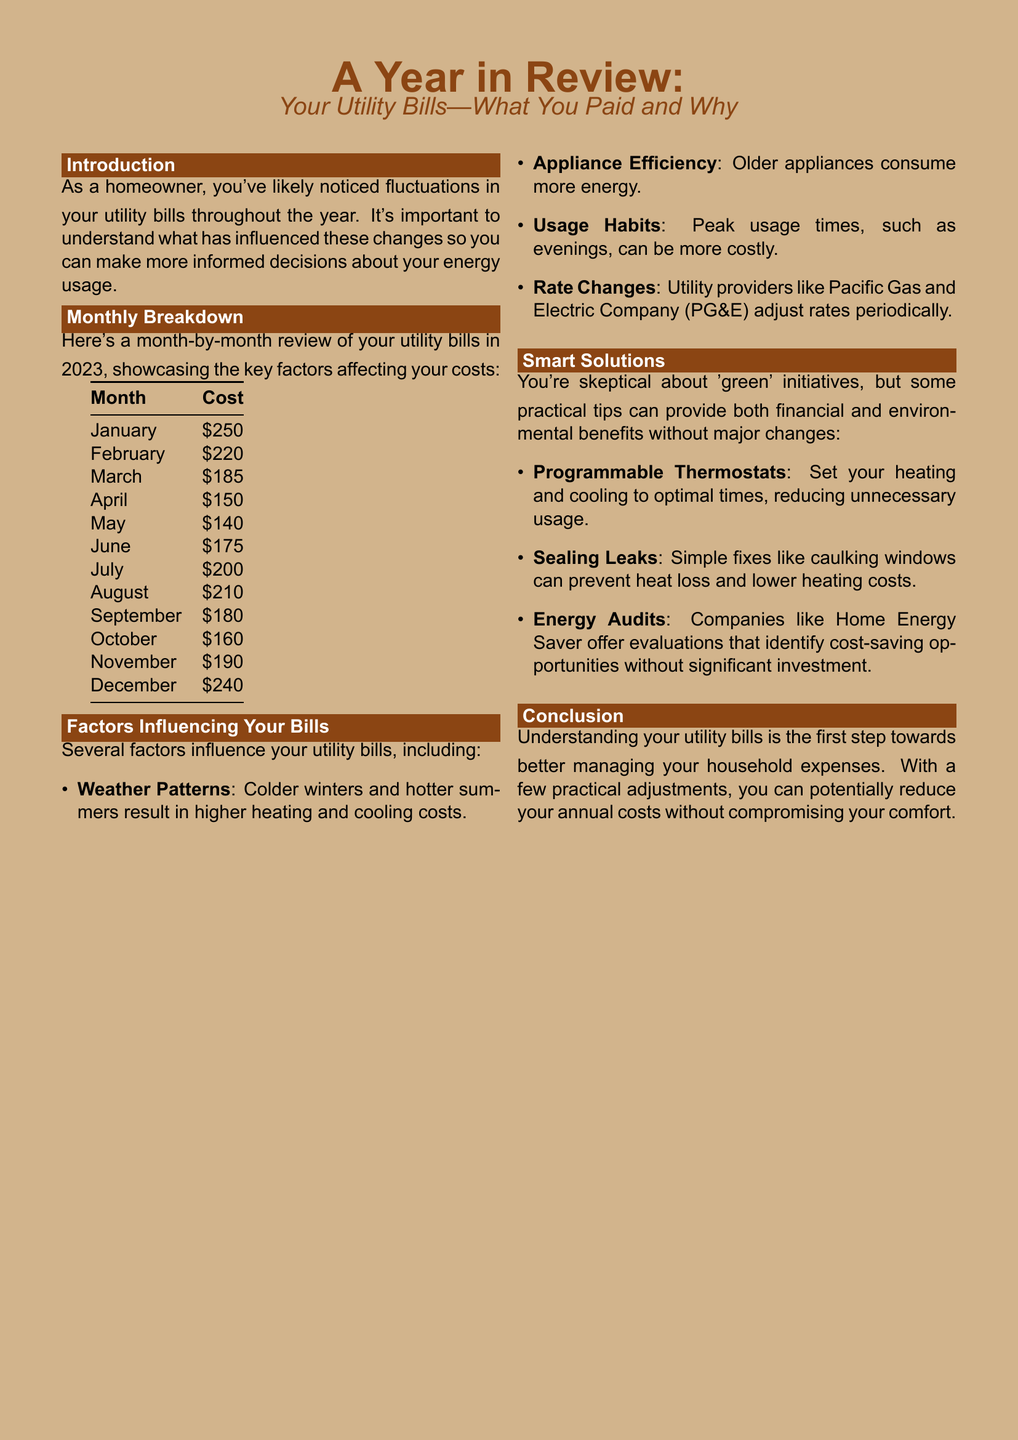What was the cost in March? The cost for March is listed in the monthly breakdown table in the document.
Answer: $185 What month had the highest utility bill? The document contains a table that shows the costs for each month, allowing us to identify the highest bill.
Answer: January What is the cost for December? The monthly breakdown in the document provides specific costs for each month, including December.
Answer: $240 What factor is influenced by weather patterns? The document lists several factors affecting utility bills and specifies that weather patterns influence certain costs.
Answer: Heating and cooling costs Which month had the lowest utility bill? Analyzing the monthly breakdown table helps to determine when the lowest bill occurred.
Answer: May What smart solution can help reduce unnecessary heating? The document provides practical tips under the smart solutions section for managing utility expenses.
Answer: Programmable Thermostats How many factors influencing bills are listed? The document includes a bullet list of factors that affect utility bills. Counting them gives the total number.
Answer: Four What appliance type is noted for consuming more energy? The document mentions appliance efficiency as a factor affecting utility costs and specifies older appliance types.
Answer: Older appliances What is the purpose of an energy audit according to the document? The smart solutions section explains what an energy audit aims to achieve for homeowners.
Answer: Identify cost-saving opportunities 